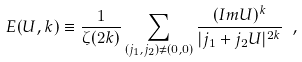<formula> <loc_0><loc_0><loc_500><loc_500>E ( U , k ) \equiv \frac { 1 } { \zeta ( 2 k ) } \sum _ { ( j _ { 1 } , j _ { 2 } ) \neq ( 0 , 0 ) } \frac { ( I m U ) ^ { k } } { | j _ { 1 } + j _ { 2 } U | ^ { 2 k } } \ ,</formula> 